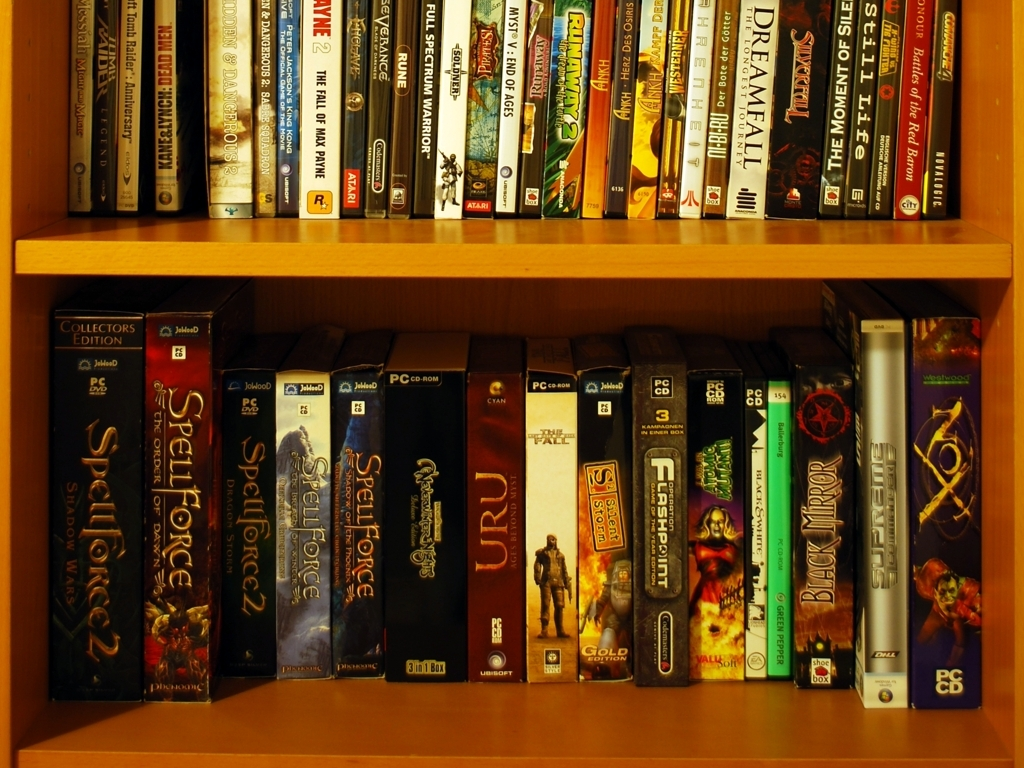Is the lighting in the image poor?
A. Yes
B. No
Answer with the option's letter from the given choices directly.
 A. 